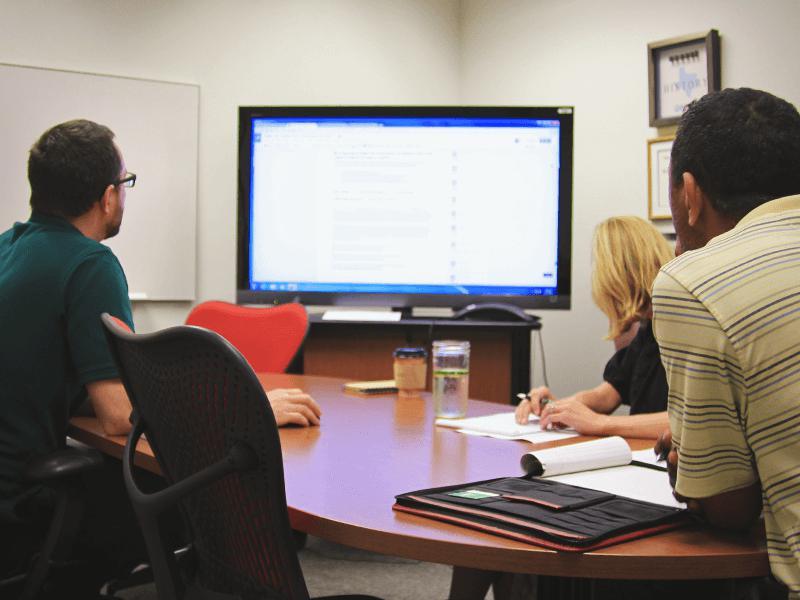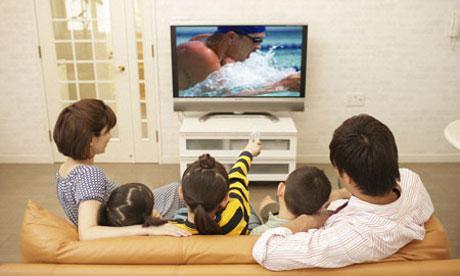The first image is the image on the left, the second image is the image on the right. For the images displayed, is the sentence "In the right image, a girl sitting on her knees in front of a TV screen has her head turned to look over her shoulder." factually correct? Answer yes or no. No. The first image is the image on the left, the second image is the image on the right. For the images shown, is this caption "One of the TVs has a blank green screen." true? Answer yes or no. No. 